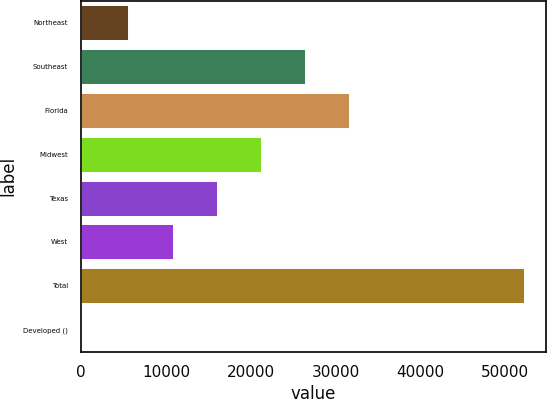Convert chart to OTSL. <chart><loc_0><loc_0><loc_500><loc_500><bar_chart><fcel>Northeast<fcel>Southeast<fcel>Florida<fcel>Midwest<fcel>Texas<fcel>West<fcel>Total<fcel>Developed ()<nl><fcel>5569<fcel>26423.4<fcel>31637<fcel>21209.8<fcel>15996.2<fcel>10782.6<fcel>52156<fcel>20<nl></chart> 